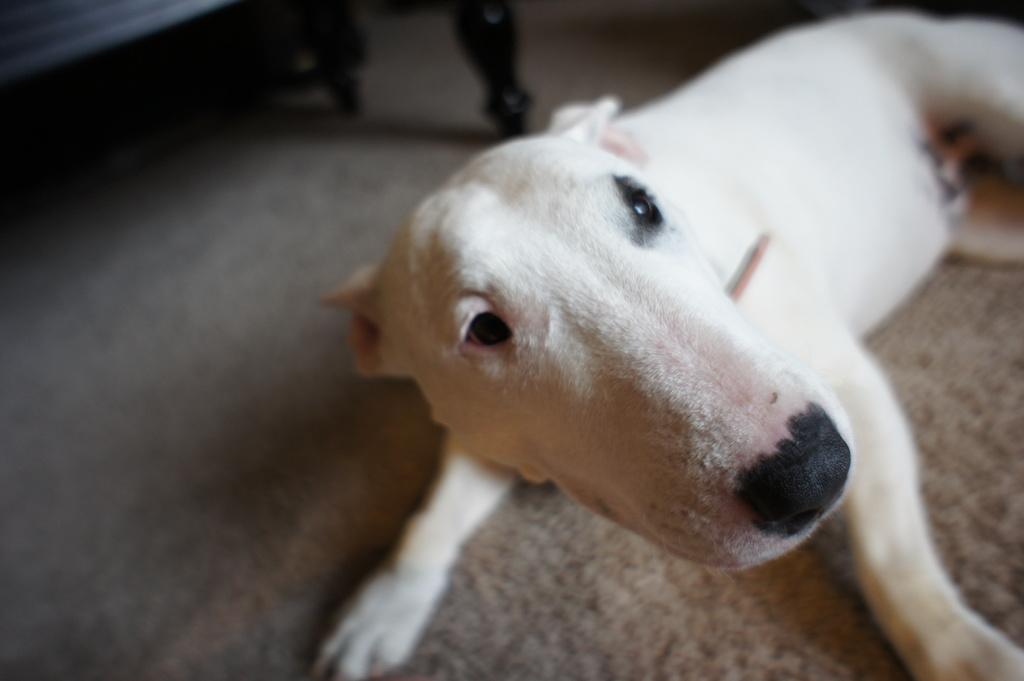Could you give a brief overview of what you see in this image? In the picture I can see a dog on the floor. It is looking like a wooden bench on the floor on the top left side of the picture. 